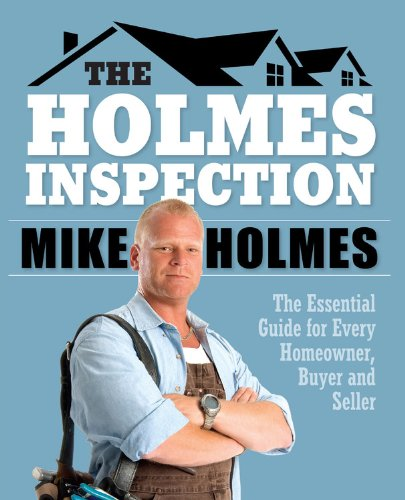What type of book is this? This book primarily falls under home improvement and real estate, providing essential guides for homeowners, buyers, and sellers, though it's categorized under Business & Money. 